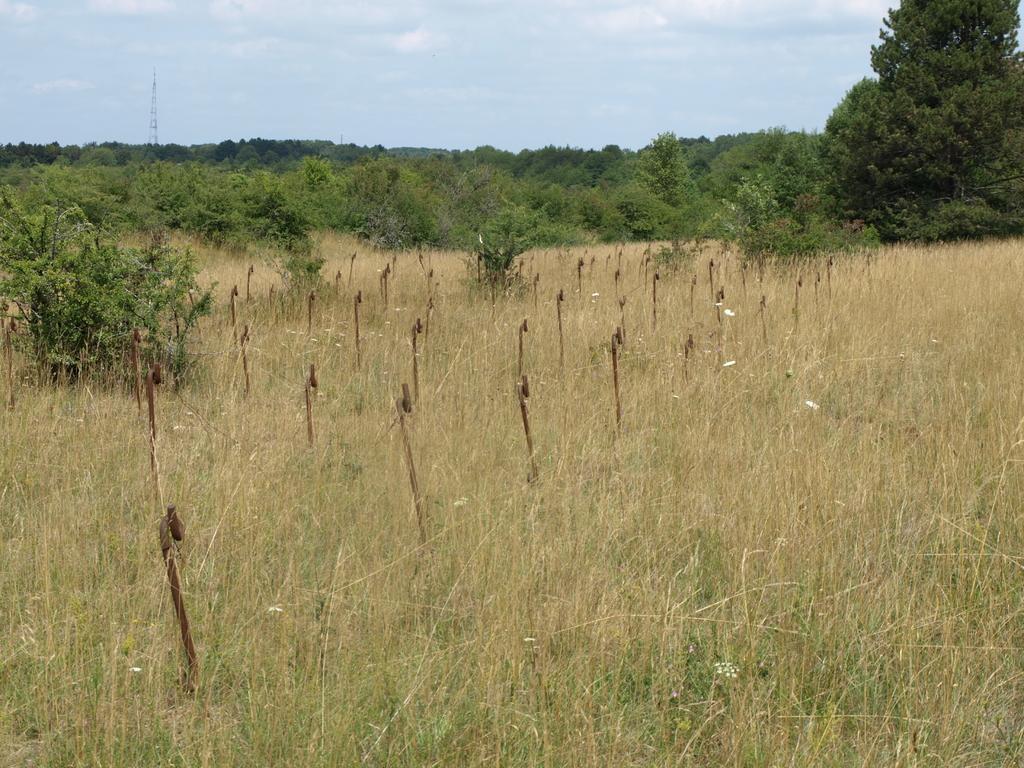Please provide a concise description of this image. In this picture I can see grass, plants, trees and some other objects on the ground. In the background I can see the sky. 